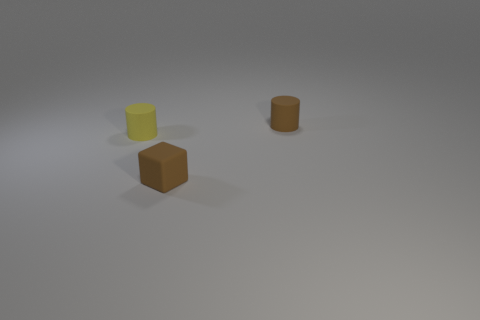What material is the yellow cylinder that is the same size as the brown block?
Offer a terse response. Rubber. Is the number of brown matte cubes that are in front of the tiny brown matte cube greater than the number of tiny brown cylinders in front of the brown matte cylinder?
Keep it short and to the point. No. Are there any small brown metallic objects that have the same shape as the tiny yellow matte object?
Give a very brief answer. No. The yellow rubber object that is the same size as the brown cylinder is what shape?
Keep it short and to the point. Cylinder. The brown matte thing that is in front of the small brown cylinder has what shape?
Your answer should be compact. Cube. Are there fewer brown objects that are in front of the brown rubber block than yellow rubber cylinders in front of the tiny yellow cylinder?
Your answer should be very brief. No. Does the cube have the same size as the brown matte object that is behind the small yellow rubber cylinder?
Provide a short and direct response. Yes. How many other yellow matte objects have the same size as the yellow matte thing?
Give a very brief answer. 0. What is the color of the cube that is the same material as the yellow cylinder?
Your answer should be very brief. Brown. Are there more big cyan cylinders than brown blocks?
Ensure brevity in your answer.  No. 